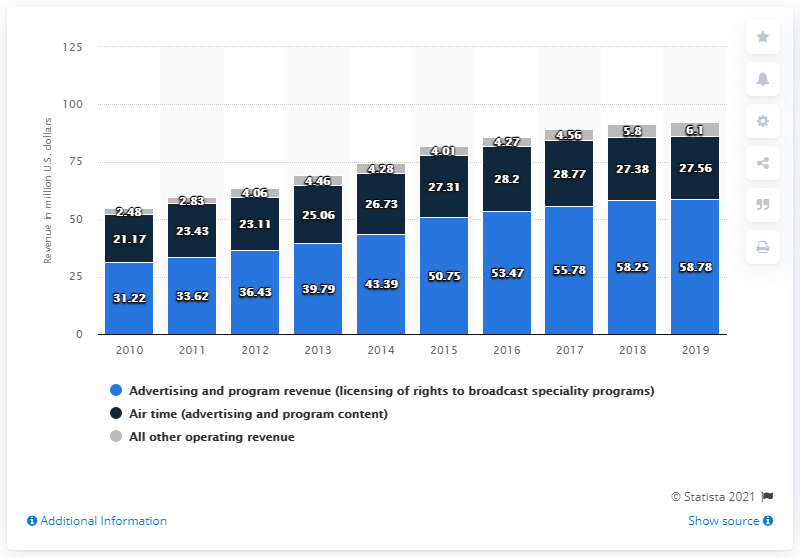Highlight a few significant elements in this photo. The highest number in 2018 was 58.25. In 2019, the combined share of the sources was 92.44%. 